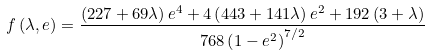<formula> <loc_0><loc_0><loc_500><loc_500>f \left ( { \lambda , e } \right ) = \frac { { \left ( { 2 2 7 + 6 9 \lambda } \right ) e ^ { 4 } + 4 \left ( { 4 4 3 + 1 4 1 \lambda } \right ) e ^ { 2 } + 1 9 2 \left ( { 3 + \lambda } \right ) } } { { 7 6 8 \left ( { 1 - e ^ { 2 } } \right ) ^ { 7 / 2 } } }</formula> 